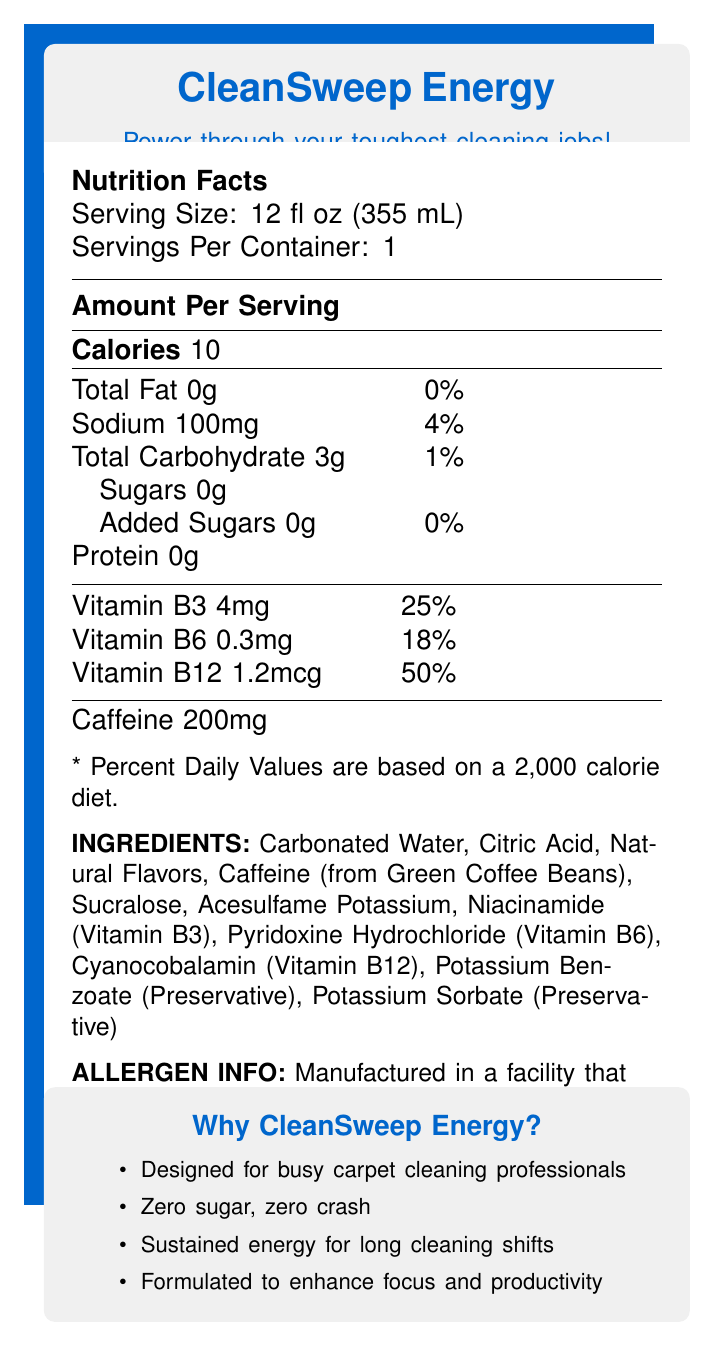What is the serving size of CleanSweep Energy? The serving size is directly listed under the "Serving Size" section in the document.
Answer: 12 fl oz (355 mL) How many calories are in one serving of CleanSweep Energy? The calories per serving are listed under the "Amount Per Serving" section as "Calories 10".
Answer: 10 How much caffeine does CleanSweep Energy contain per serving? The amount of caffeine is listed at the end of the "Amount Per Serving" section.
Answer: 200mg What percentage of the daily value of Vitamin B12 does one serving of CleanSweep Energy provide? This information is listed under the vitamins section as "Vitamin B12 1.2mcg 50%".
Answer: 50% What are the primary ingredients in CleanSweep Energy? The list of primary ingredients is detailed under the "Ingredients" section.
Answer: Carbonated Water, Citric Acid, Natural Flavors, Caffeine (from Green Coffee Beans), Sucralose, Acesulfame Potassium, Niacinamide (Vitamin B3), Pyridoxine Hydrochloride (Vitamin B6), Cyanocobalamin (Vitamin B12), Potassium Benzoate (Preservative), Potassium Sorbate (Preservative) What is the sodium content in CleanSweep Energy and its percentage of the daily value? The sodium content and its daily value percentage are listed under the "Amount Per Serving" section as "Sodium 100mg 4%".
Answer: 100mg, 4% What are some of the marketing claims made for CleanSweep Energy? A. Zero crashes B. Enhances focus C. Contains added sugars D. Designed for busy professionals The marketing claims listed in the document include: "Designed for busy carpet cleaning professionals", "Zero sugar, zero crash", "Sustained energy for long cleaning shifts", and "Formulated to enhance focus and productivity". None of the claims mention containing added sugars, which makes option C the correct answer.
Answer: C. Contains added sugars What should you do after opening the can of CleanSweep Energy? A. Freeze it B. Refrigerate and consume within 48 hours C. Refrigerate and consume within 24 hours D. Leave it at room temperature and consume within 24 hours The storage instructions specified in the document are: "Refrigerate after opening. Consume within 24 hours of opening for best taste."
Answer: C. Refrigerate and consume within 24 hours Does CleanSweep Energy contain any added sugars? The document mentions "Added Sugars 0g" in the Nutrition Facts section.
Answer: No Is CleanSweep Energy suitable for carpet cleaning professionals who have soy allergies? While the drink itself does not list soy as an ingredient, the allergen information specifies that it's "Manufactured in a facility that processes milk, soy, and tree nuts", suggesting a possibility of cross-contamination.
Answer: Maybe Summarize the main idea of the document. The document promotes CleanSweep Energy by highlighting its benefits, ingredients, nutritional information, allergen disclaimer, and storage instructions, emphasizing its use for professionals needing sustained energy and focus.
Answer: CleanSweep Energy is a low-calorie, caffeine-rich energy drink designed for carpet cleaning professionals. It provides sustained energy without sugar crashes, includes essential vitamins, and is meant to enhance focus and productivity during long cleaning shifts. What is the source of caffeine in CleanSweep Energy? The ingredient list includes "Caffeine (from Green Coffee Beans)".
Answer: Green Coffee Beans What is the total carbohydrate content in CleanSweep Energy? The total carbohydrate content is listed under the "Amount Per Serving" section.
Answer: 3g Can I find information on the price of CleanSweep Energy in the document? The document does not provide any details regarding the pricing of CleanSweep Energy.
Answer: Not enough information 